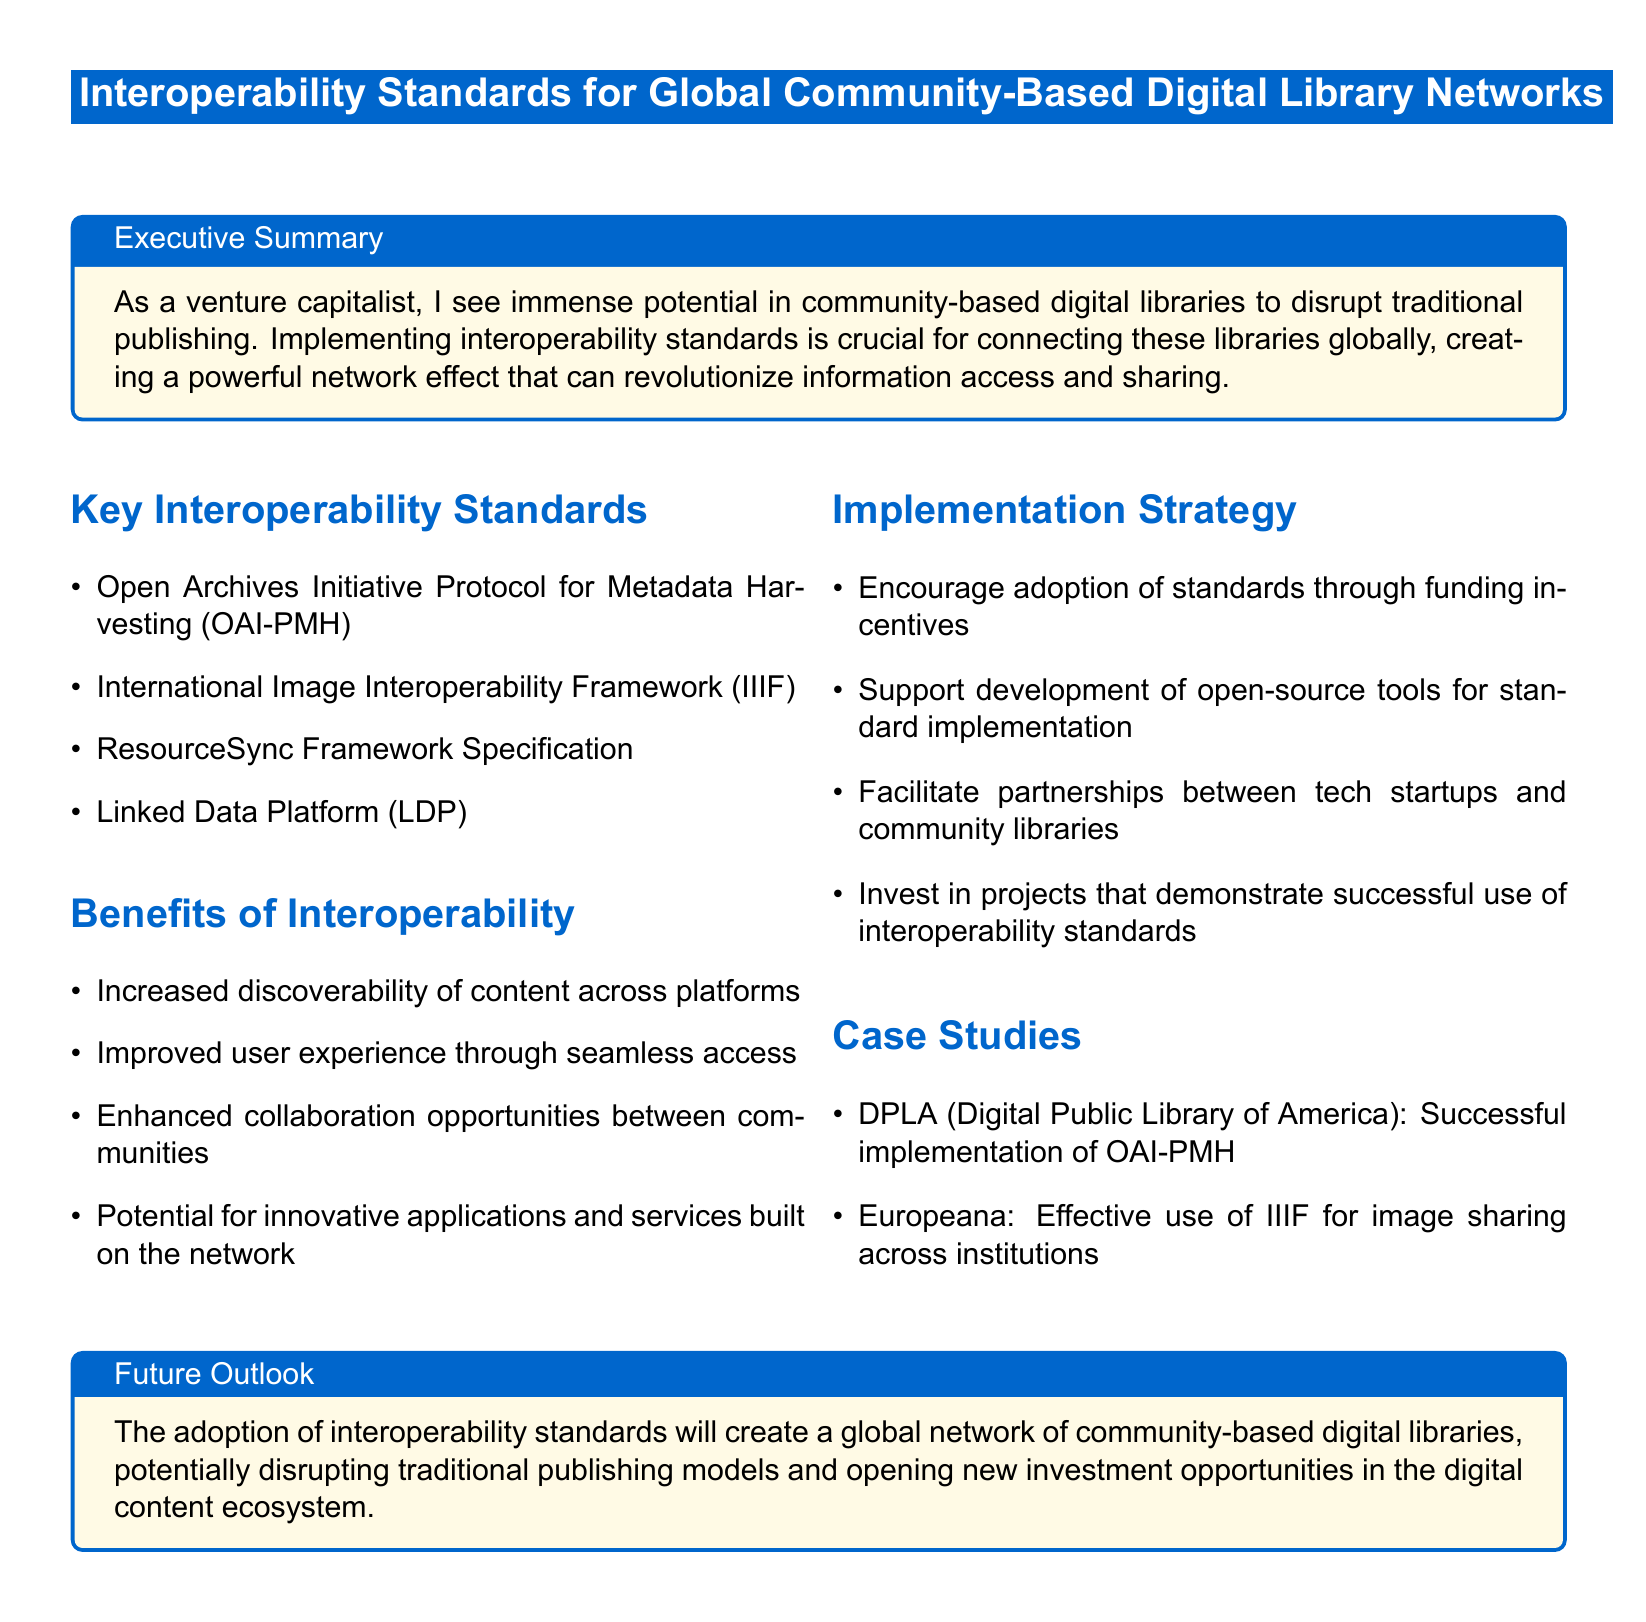What is the title of the document? The title of the document is prominently displayed at the top, indicating the focus on interoperability standards for digital libraries.
Answer: Interoperability Standards for Global Community-Based Digital Library Networks What is one of the key interoperability standards mentioned? The document lists several key interoperability standards in a section dedicated to them.
Answer: Open Archives Initiative Protocol for Metadata Harvesting (OAI-PMH) What is a benefit of interoperability according to the document? The document outlines multiple benefits that arise from implementing interoperability standards, focusing on user experience and collaboration.
Answer: Increased discoverability of content across platforms What implementation strategy is suggested in the document? The document provides a list of implementation strategies to encourage the adoption of interoperability standards.
Answer: Encourage adoption of standards through funding incentives Which case study exemplifies successful implementation of OAI-PMH? The document includes case studies illustrating successful uses of interoperability standards, one specifically for OAI-PMH.
Answer: DPLA (Digital Public Library of America) What color is used for the box containing the executive summary? The executive summary is highlighted within a colored box that is specifically defined in the document.
Answer: Second color What major effect is anticipated from the adoption of interoperability standards? The document discusses the broader implications of adopting these standards, specifically concerning traditional publishing models.
Answer: Disrupting traditional publishing models 